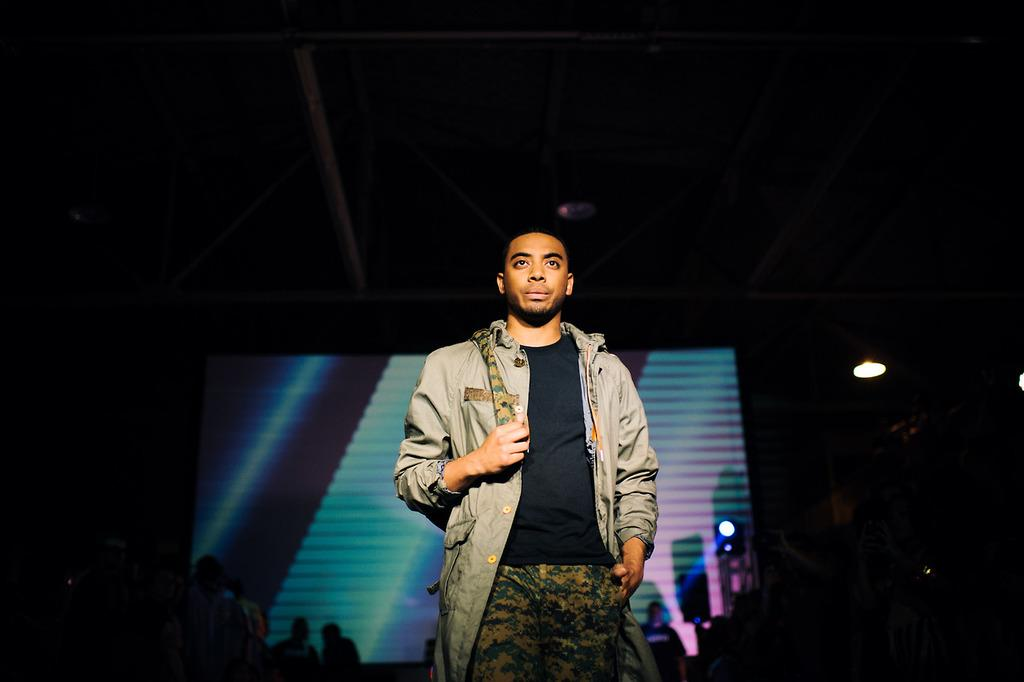What is the main subject in the foreground of the image? There is a person visible in the foreground of the image. What can be seen in the background of the image? There are lights, a screen, and other persons visible in the background of the image. How would you describe the lighting conditions in the background? The background of the image is very dark. What type of silver is being used by the duck on the branch in the image? There is no duck or branch present in the image, and therefore no silver can be associated with them. 